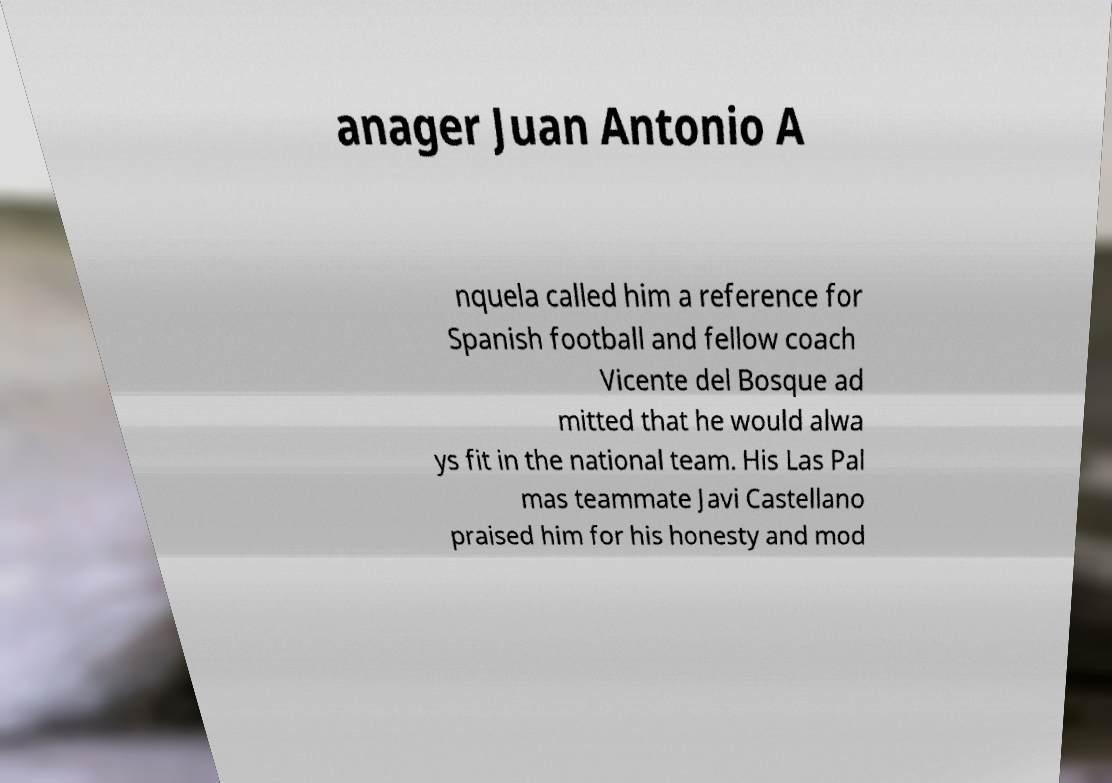Can you accurately transcribe the text from the provided image for me? anager Juan Antonio A nquela called him a reference for Spanish football and fellow coach Vicente del Bosque ad mitted that he would alwa ys fit in the national team. His Las Pal mas teammate Javi Castellano praised him for his honesty and mod 